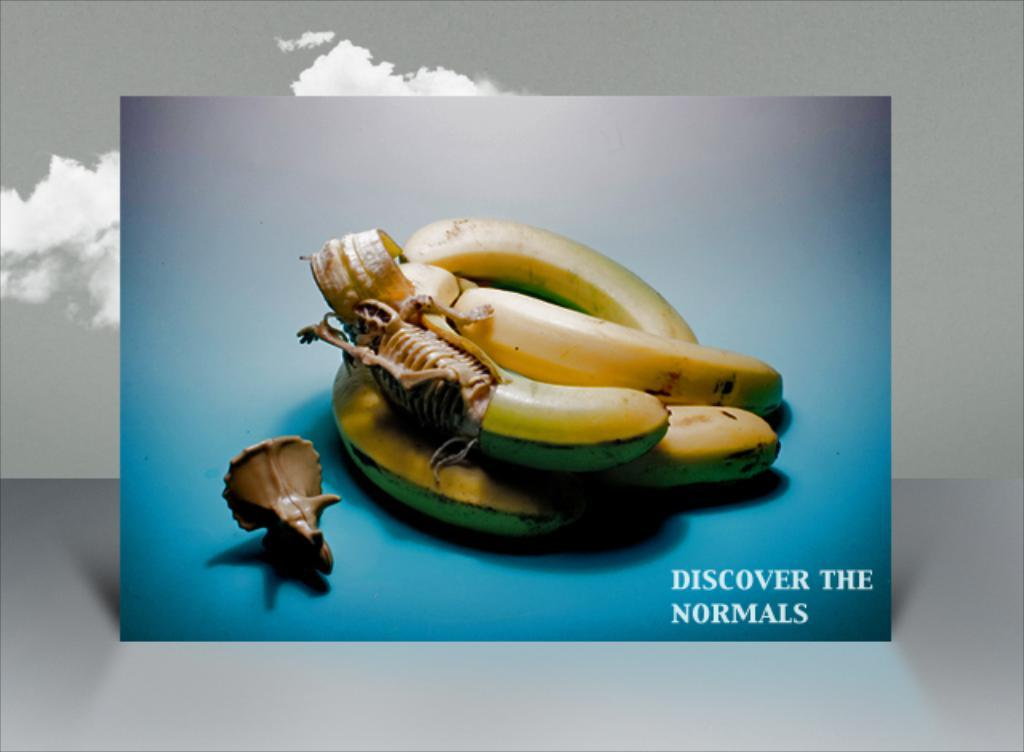What is the main subject in the foreground of the poster? There are bananas in the foreground of the poster. What is placed on one of the bananas? There is a toy skeleton on theon on the open banana. What other toy can be seen in the image? There is a skull toy on a blue surface. How many forks are used to hold the bridge in the image? There is no bridge or fork present in the image; it features bananas with toy skeletons and a skull toy. What type of seed is visible on the banana in the image? There are no seeds visible on the banana in the image, as it is a toy skeleton placed on an open banana. 